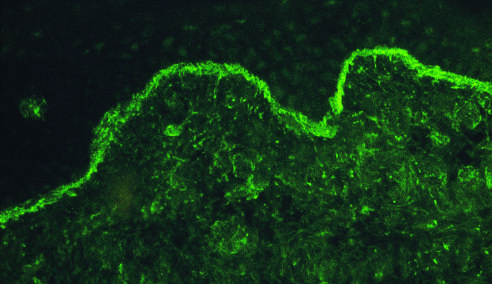do the relative locations, sizes, and distances between genes reveal deposits of ig along the dermo-epidermal junction?
Answer the question using a single word or phrase. No 